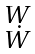<formula> <loc_0><loc_0><loc_500><loc_500>\begin{smallmatrix} W \\ \dot { W } \end{smallmatrix}</formula> 